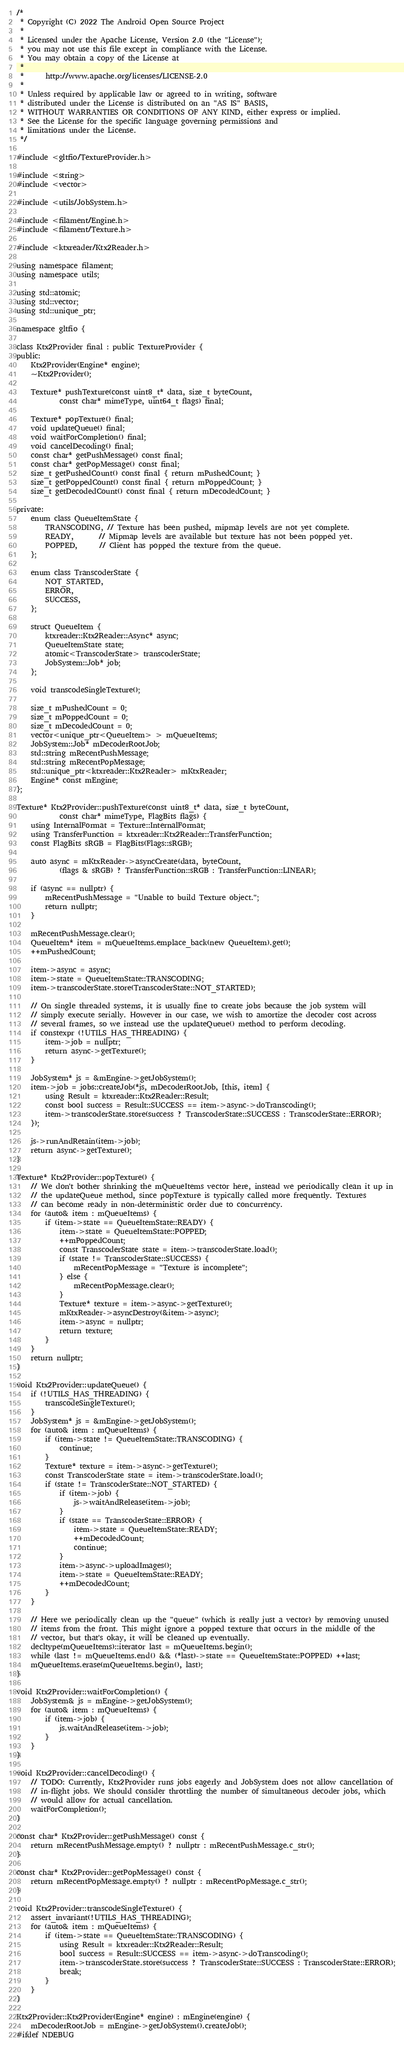Convert code to text. <code><loc_0><loc_0><loc_500><loc_500><_C++_>/*
 * Copyright (C) 2022 The Android Open Source Project
 *
 * Licensed under the Apache License, Version 2.0 (the "License");
 * you may not use this file except in compliance with the License.
 * You may obtain a copy of the License at
 *
 *      http://www.apache.org/licenses/LICENSE-2.0
 *
 * Unless required by applicable law or agreed to in writing, software
 * distributed under the License is distributed on an "AS IS" BASIS,
 * WITHOUT WARRANTIES OR CONDITIONS OF ANY KIND, either express or implied.
 * See the License for the specific language governing permissions and
 * limitations under the License.
 */

#include <gltfio/TextureProvider.h>

#include <string>
#include <vector>

#include <utils/JobSystem.h>

#include <filament/Engine.h>
#include <filament/Texture.h>

#include <ktxreader/Ktx2Reader.h>

using namespace filament;
using namespace utils;

using std::atomic;
using std::vector;
using std::unique_ptr;

namespace gltfio {

class Ktx2Provider final : public TextureProvider {
public:
    Ktx2Provider(Engine* engine);
    ~Ktx2Provider();

    Texture* pushTexture(const uint8_t* data, size_t byteCount,
            const char* mimeType, uint64_t flags) final;

    Texture* popTexture() final;
    void updateQueue() final;
    void waitForCompletion() final;
    void cancelDecoding() final;
    const char* getPushMessage() const final;
    const char* getPopMessage() const final;
    size_t getPushedCount() const final { return mPushedCount; }
    size_t getPoppedCount() const final { return mPoppedCount; }
    size_t getDecodedCount() const final { return mDecodedCount; }

private:
    enum class QueueItemState {
        TRANSCODING, // Texture has been pushed, mipmap levels are not yet complete.
        READY,       // Mipmap levels are available but texture has not been popped yet.
        POPPED,      // Client has popped the texture from the queue.
    };

    enum class TranscoderState {
        NOT_STARTED,
        ERROR,
        SUCCESS,
    };

    struct QueueItem {
        ktxreader::Ktx2Reader::Async* async;
        QueueItemState state;
        atomic<TranscoderState> transcoderState;
        JobSystem::Job* job;
    };

    void transcodeSingleTexture();

    size_t mPushedCount = 0;
    size_t mPoppedCount = 0;
    size_t mDecodedCount = 0;
    vector<unique_ptr<QueueItem> > mQueueItems;
    JobSystem::Job* mDecoderRootJob;
    std::string mRecentPushMessage;
    std::string mRecentPopMessage;
    std::unique_ptr<ktxreader::Ktx2Reader> mKtxReader;
    Engine* const mEngine;
};

Texture* Ktx2Provider::pushTexture(const uint8_t* data, size_t byteCount,
            const char* mimeType, FlagBits flags) {
    using InternalFormat = Texture::InternalFormat;
    using TransferFunction = ktxreader::Ktx2Reader::TransferFunction;
    const FlagBits sRGB = FlagBits(Flags::sRGB);

    auto async = mKtxReader->asyncCreate(data, byteCount,
            (flags & sRGB) ? TransferFunction::sRGB : TransferFunction::LINEAR);

    if (async == nullptr) {
        mRecentPushMessage = "Unable to build Texture object.";
        return nullptr;
    }

    mRecentPushMessage.clear();
    QueueItem* item = mQueueItems.emplace_back(new QueueItem).get();
    ++mPushedCount;

    item->async = async;
    item->state = QueueItemState::TRANSCODING;
    item->transcoderState.store(TranscoderState::NOT_STARTED);

    // On single threaded systems, it is usually fine to create jobs because the job system will
    // simply execute serially. However in our case, we wish to amortize the decoder cost across
    // several frames, so we instead use the updateQueue() method to perform decoding.
    if constexpr (!UTILS_HAS_THREADING) {
        item->job = nullptr;
        return async->getTexture();
    }

    JobSystem* js = &mEngine->getJobSystem();
    item->job = jobs::createJob(*js, mDecoderRootJob, [this, item] {
        using Result = ktxreader::Ktx2Reader::Result;
        const bool success = Result::SUCCESS == item->async->doTranscoding();
        item->transcoderState.store(success ? TranscoderState::SUCCESS : TranscoderState::ERROR);
    });

    js->runAndRetain(item->job);
    return async->getTexture();
}

Texture* Ktx2Provider::popTexture() {
    // We don't bother shrinking the mQueueItems vector here, instead we periodically clean it up in
    // the updateQueue method, since popTexture is typically called more frequently. Textures
    // can become ready in non-deterministic order due to concurrency.
    for (auto& item : mQueueItems) {
        if (item->state == QueueItemState::READY) {
            item->state = QueueItemState::POPPED;
            ++mPoppedCount;
            const TranscoderState state = item->transcoderState.load();
            if (state != TranscoderState::SUCCESS) {
                mRecentPopMessage = "Texture is incomplete";
            } else {
                mRecentPopMessage.clear();
            }
            Texture* texture = item->async->getTexture();
            mKtxReader->asyncDestroy(&item->async);
            item->async = nullptr;
            return texture;
        }
    }
    return nullptr;
}

void Ktx2Provider::updateQueue() {
    if (!UTILS_HAS_THREADING) {
        transcodeSingleTexture();
    }
    JobSystem* js = &mEngine->getJobSystem();
    for (auto& item : mQueueItems) {
        if (item->state != QueueItemState::TRANSCODING) {
            continue;
        }
        Texture* texture = item->async->getTexture();
        const TranscoderState state = item->transcoderState.load();
        if (state != TranscoderState::NOT_STARTED) {
            if (item->job) {
                js->waitAndRelease(item->job);
            }
            if (state == TranscoderState::ERROR) {
                item->state = QueueItemState::READY;
                ++mDecodedCount;
                continue;
            }
            item->async->uploadImages();
            item->state = QueueItemState::READY;
            ++mDecodedCount;
        }
    }

    // Here we periodically clean up the "queue" (which is really just a vector) by removing unused
    // items from the front. This might ignore a popped texture that occurs in the middle of the
    // vector, but that's okay, it will be cleaned up eventually.
    decltype(mQueueItems)::iterator last = mQueueItems.begin();
    while (last != mQueueItems.end() && (*last)->state == QueueItemState::POPPED) ++last;
    mQueueItems.erase(mQueueItems.begin(), last);
}

void Ktx2Provider::waitForCompletion() {
    JobSystem& js = mEngine->getJobSystem();
    for (auto& item : mQueueItems) {
        if (item->job) {
            js.waitAndRelease(item->job);
        }
    }
}

void Ktx2Provider::cancelDecoding() {
    // TODO: Currently, Ktx2Provider runs jobs eagerly and JobSystem does not allow cancellation of
    // in-flight jobs. We should consider throttling the number of simultaneous decoder jobs, which
    // would allow for actual cancellation.
    waitForCompletion();
}

const char* Ktx2Provider::getPushMessage() const {
    return mRecentPushMessage.empty() ? nullptr : mRecentPushMessage.c_str();
}

const char* Ktx2Provider::getPopMessage() const {
    return mRecentPopMessage.empty() ? nullptr : mRecentPopMessage.c_str();
}

void Ktx2Provider::transcodeSingleTexture() {
    assert_invariant(!UTILS_HAS_THREADING);
    for (auto& item : mQueueItems) {
        if (item->state == QueueItemState::TRANSCODING) {
            using Result = ktxreader::Ktx2Reader::Result;
            bool success = Result::SUCCESS == item->async->doTranscoding();
            item->transcoderState.store(success ? TranscoderState::SUCCESS : TranscoderState::ERROR);
            break;
        }
    }
}

Ktx2Provider::Ktx2Provider(Engine* engine) : mEngine(engine) {
    mDecoderRootJob = mEngine->getJobSystem().createJob();
#ifdef NDEBUG</code> 